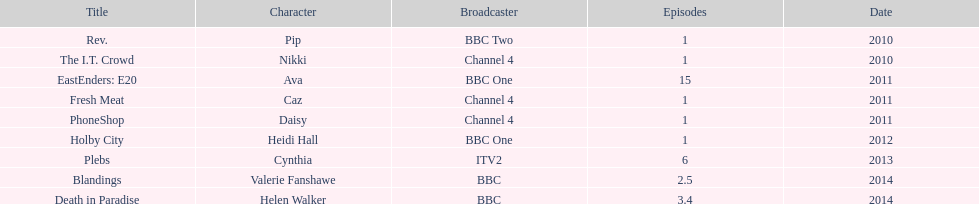What is the number of television roles for this actress? 9. 